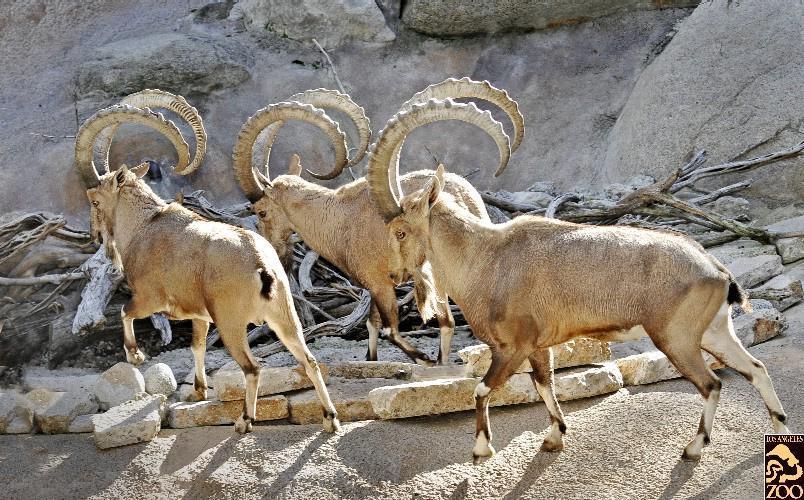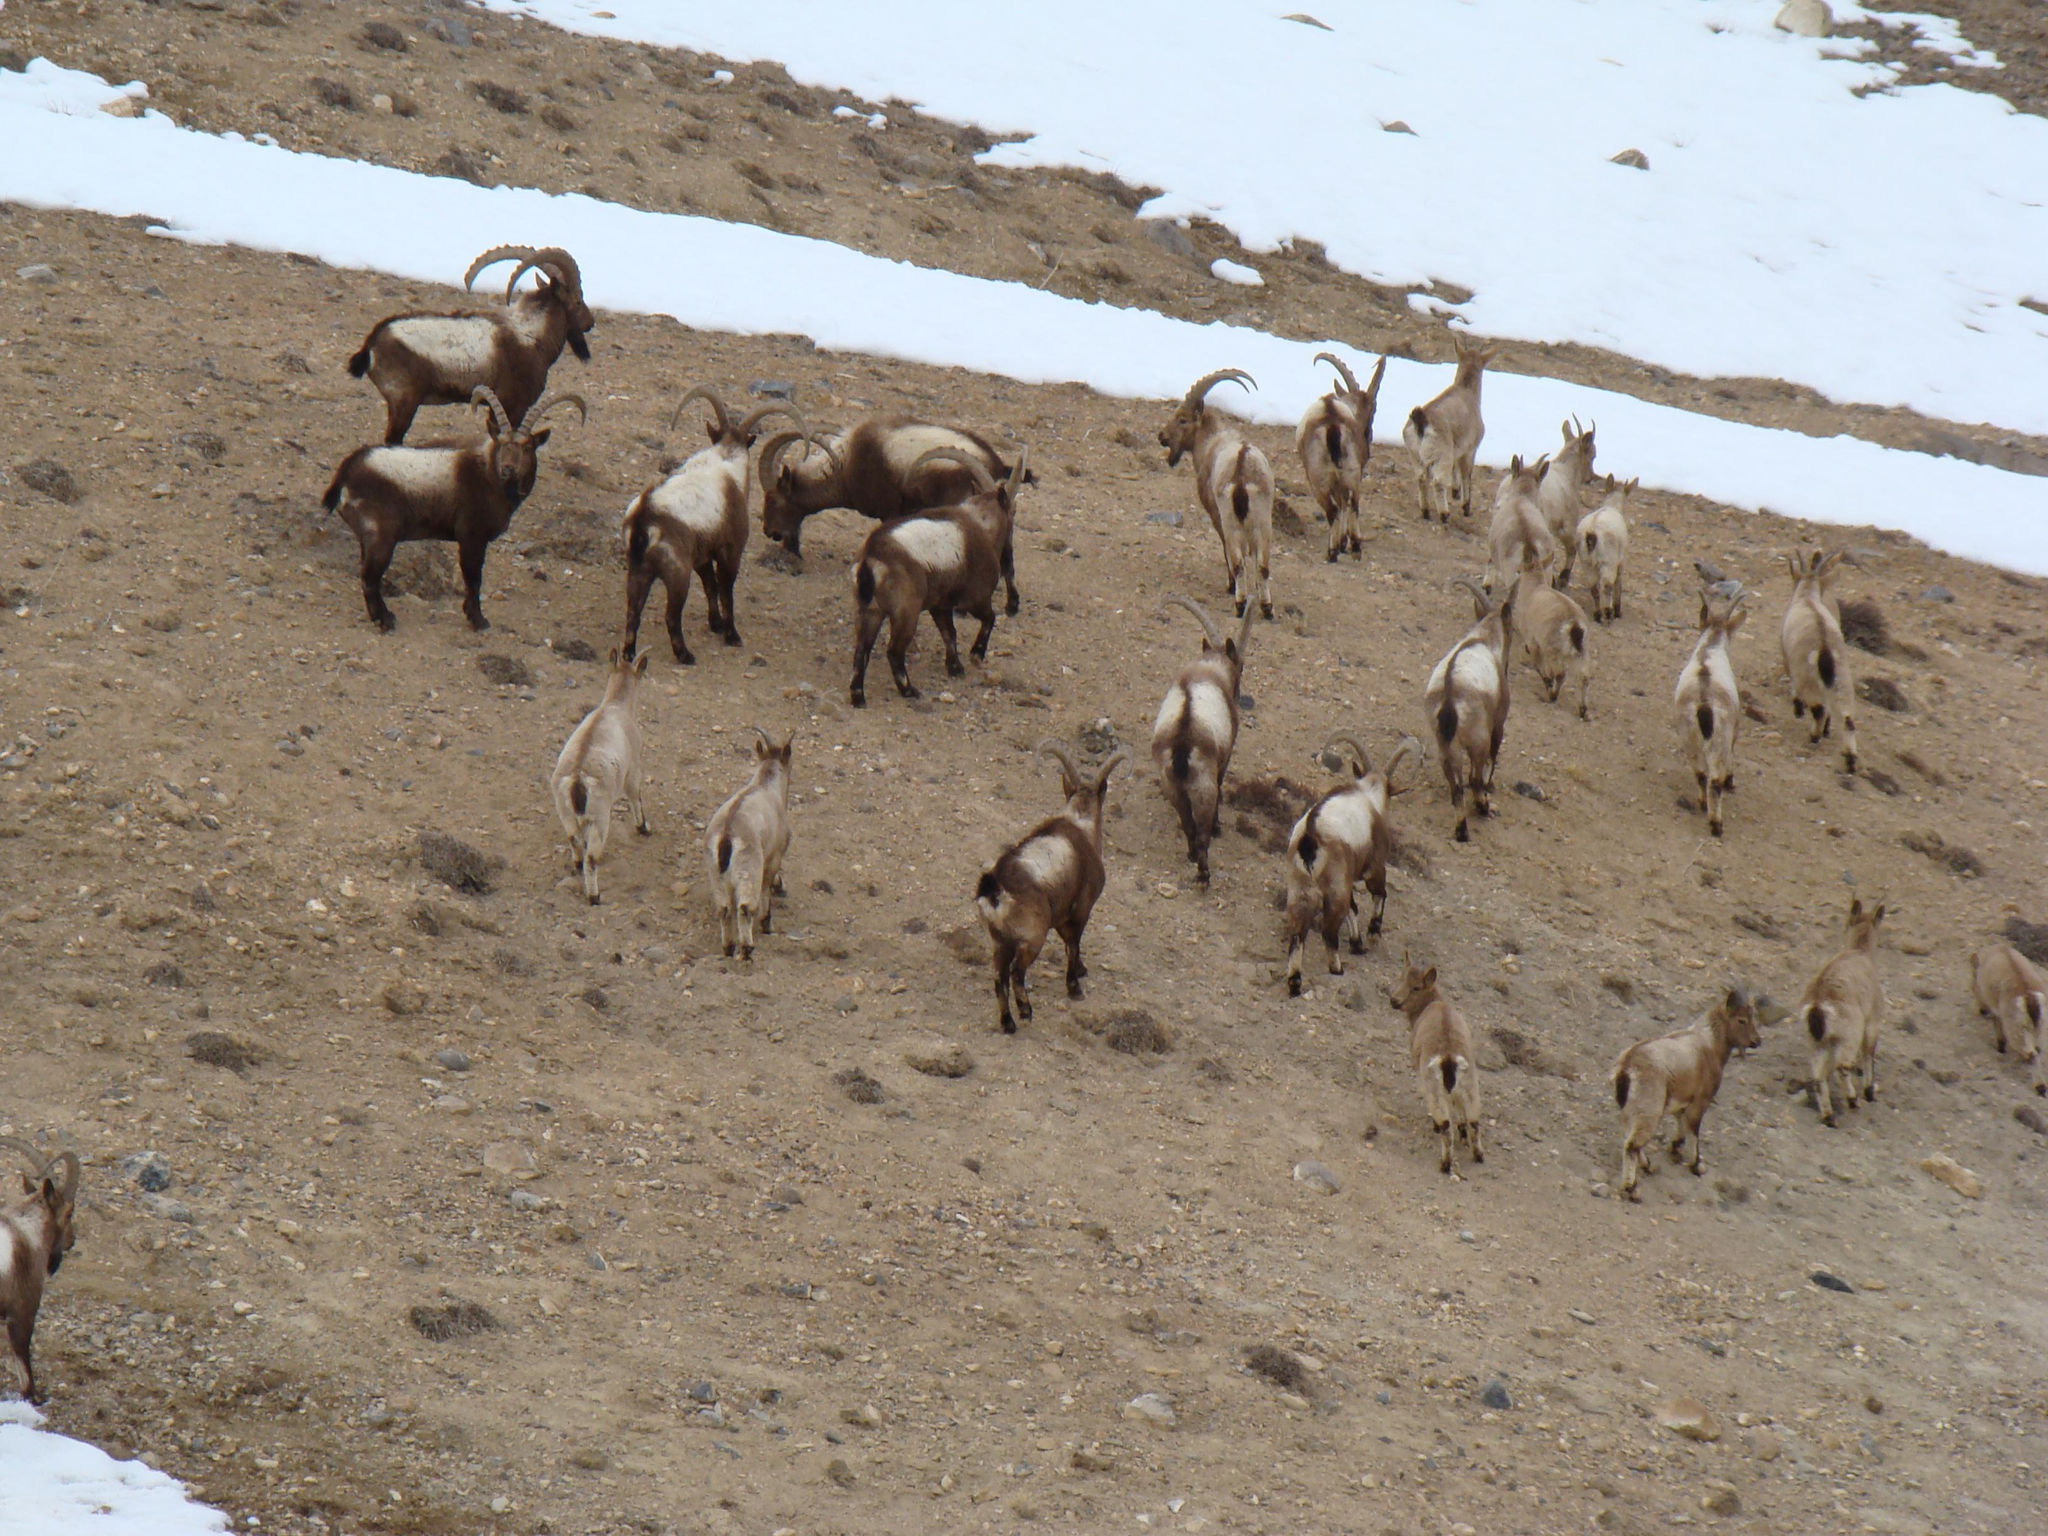The first image is the image on the left, the second image is the image on the right. Given the left and right images, does the statement "At least one antelope is standing on a rocky grassless mountain." hold true? Answer yes or no. Yes. The first image is the image on the left, the second image is the image on the right. Considering the images on both sides, is "An area of sky blue is visible behind at least one mountain." valid? Answer yes or no. No. 